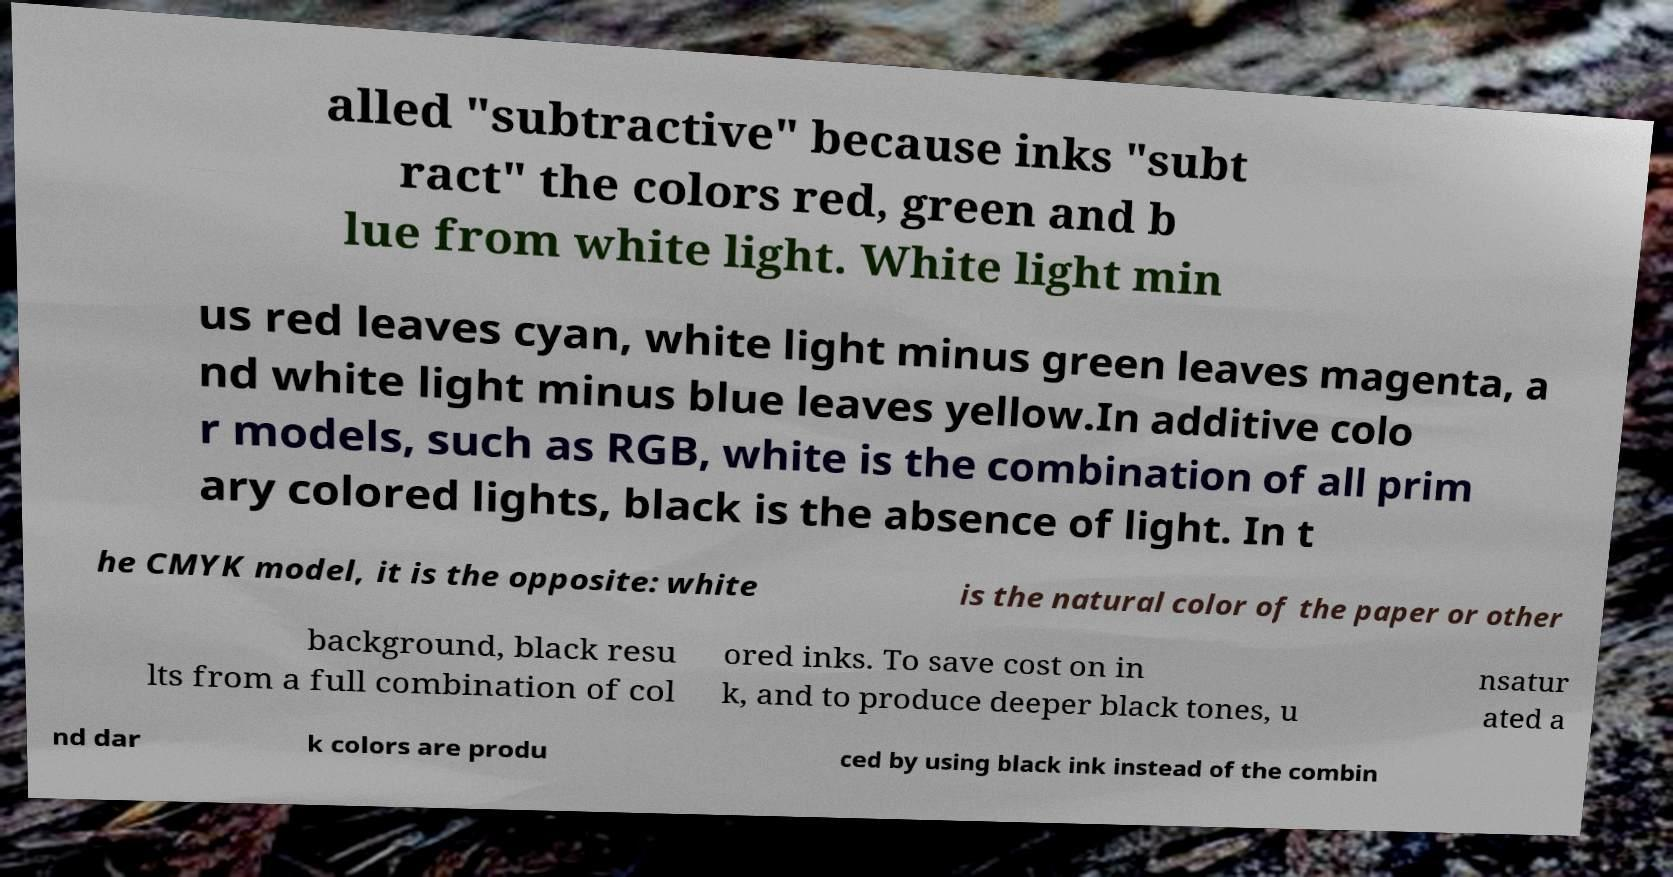Can you read and provide the text displayed in the image?This photo seems to have some interesting text. Can you extract and type it out for me? alled "subtractive" because inks "subt ract" the colors red, green and b lue from white light. White light min us red leaves cyan, white light minus green leaves magenta, a nd white light minus blue leaves yellow.In additive colo r models, such as RGB, white is the combination of all prim ary colored lights, black is the absence of light. In t he CMYK model, it is the opposite: white is the natural color of the paper or other background, black resu lts from a full combination of col ored inks. To save cost on in k, and to produce deeper black tones, u nsatur ated a nd dar k colors are produ ced by using black ink instead of the combin 